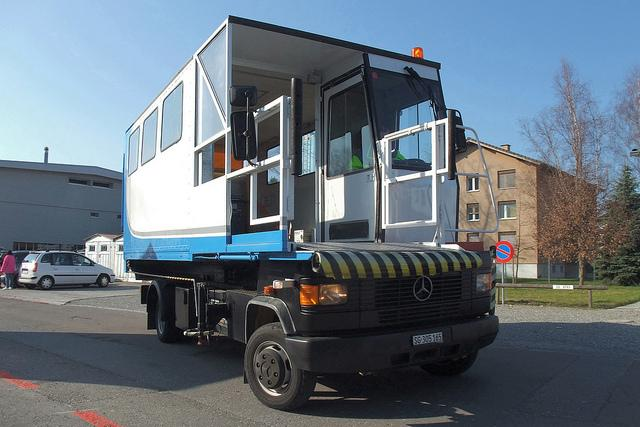What company made this vehicle? mercedes 